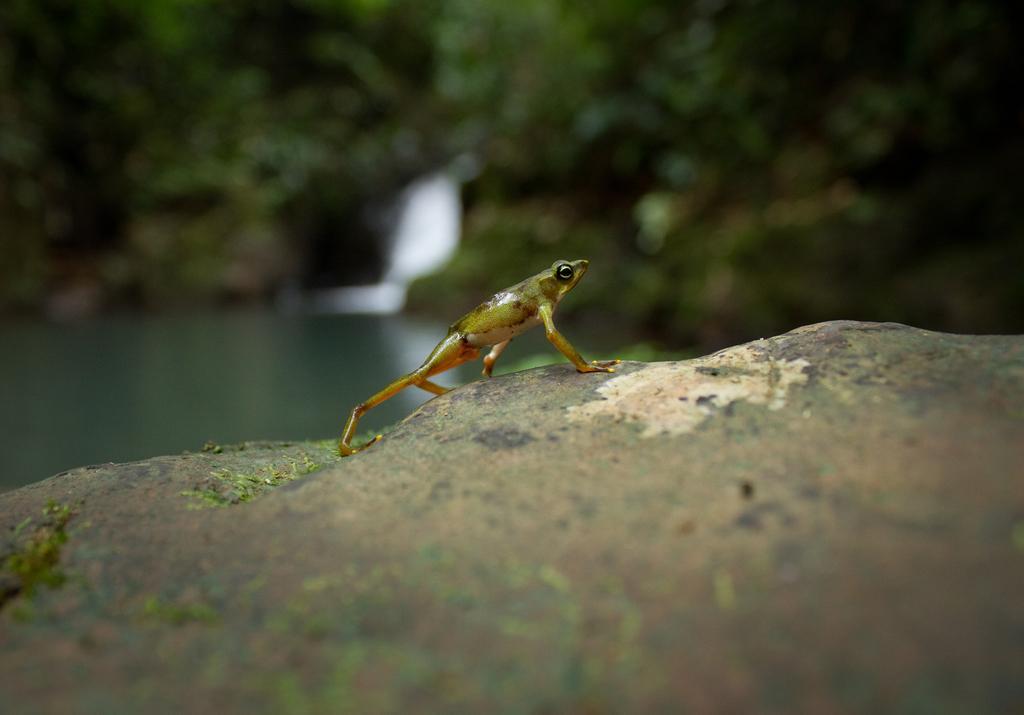How would you summarize this image in a sentence or two? In this image we can see an amphibian which is in green color is on stone and in the background of the image there are some trees and water. 